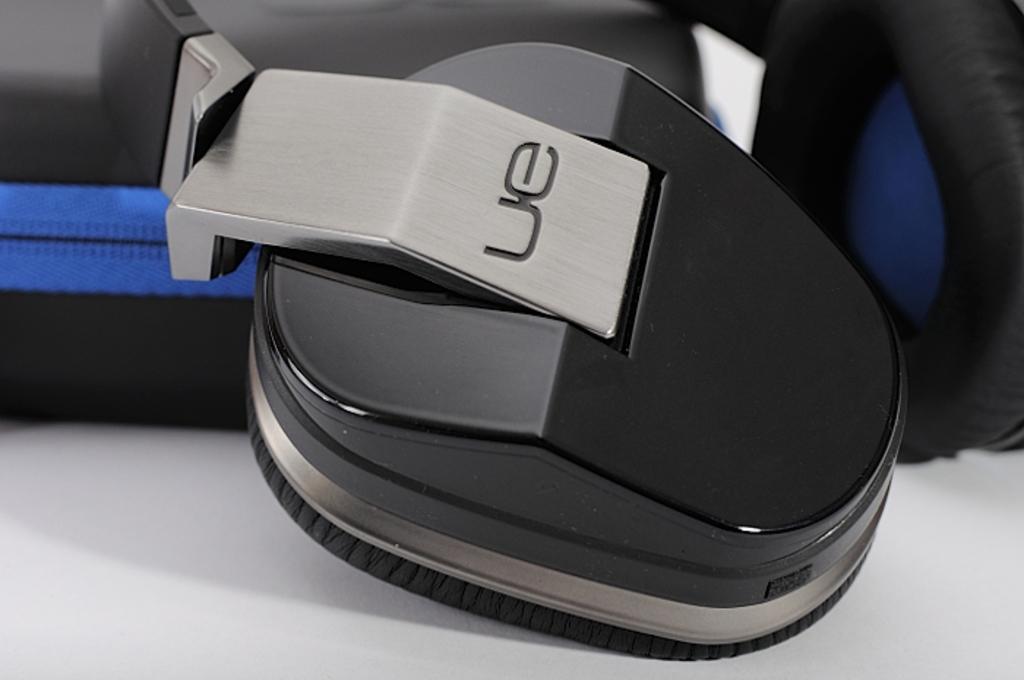Could you give a brief overview of what you see in this image? It is the headset in black color. 